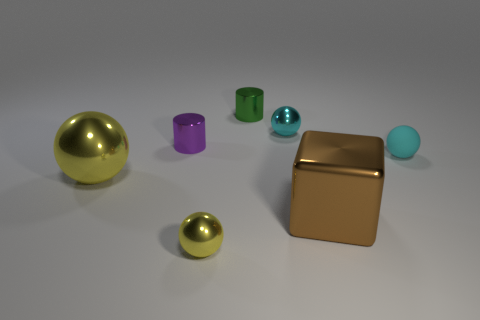Subtract 1 balls. How many balls are left? 3 Add 2 large metal spheres. How many objects exist? 9 Subtract all cylinders. How many objects are left? 5 Add 4 cylinders. How many cylinders are left? 6 Add 1 large green metallic blocks. How many large green metallic blocks exist? 1 Subtract 0 blue cubes. How many objects are left? 7 Subtract all tiny cyan rubber balls. Subtract all brown blocks. How many objects are left? 5 